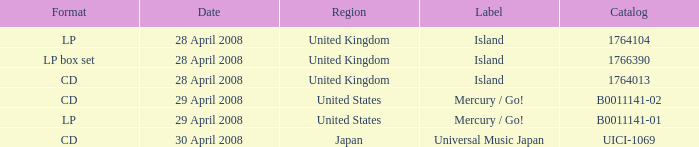What is the Label of the UICI-1069 Catalog? Universal Music Japan. 